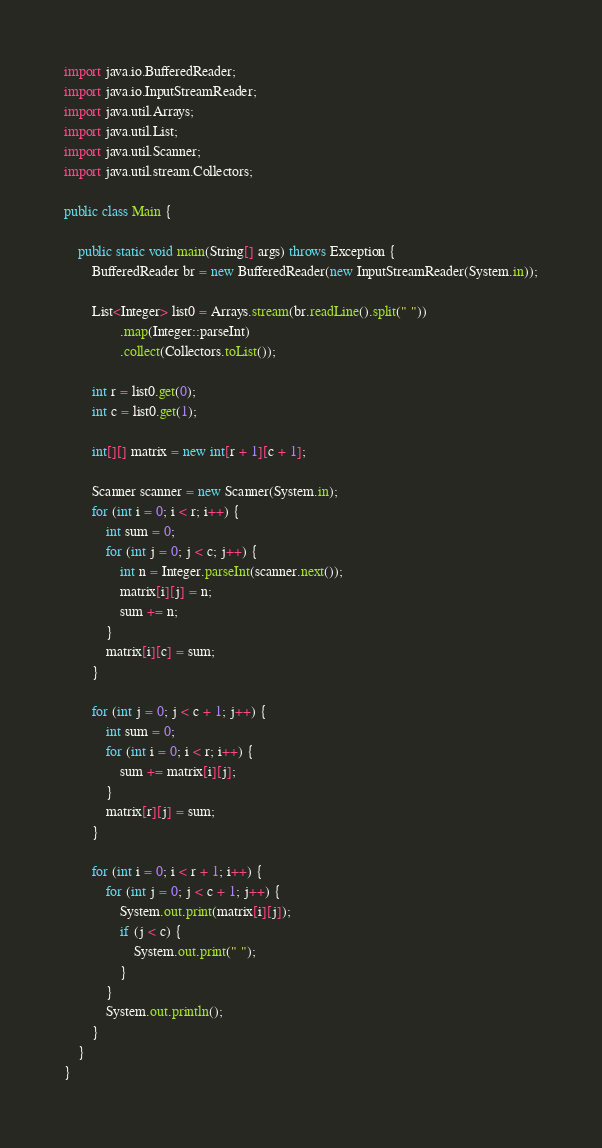Convert code to text. <code><loc_0><loc_0><loc_500><loc_500><_Java_>import java.io.BufferedReader;
import java.io.InputStreamReader;
import java.util.Arrays;
import java.util.List;
import java.util.Scanner;
import java.util.stream.Collectors;

public class Main {

    public static void main(String[] args) throws Exception {
        BufferedReader br = new BufferedReader(new InputStreamReader(System.in));

        List<Integer> list0 = Arrays.stream(br.readLine().split(" "))
                .map(Integer::parseInt)
                .collect(Collectors.toList());

        int r = list0.get(0);
        int c = list0.get(1);

        int[][] matrix = new int[r + 1][c + 1];

        Scanner scanner = new Scanner(System.in);
        for (int i = 0; i < r; i++) {
            int sum = 0;
            for (int j = 0; j < c; j++) {
                int n = Integer.parseInt(scanner.next());
                matrix[i][j] = n;
                sum += n;
            }
            matrix[i][c] = sum;
        }

        for (int j = 0; j < c + 1; j++) {
            int sum = 0;
            for (int i = 0; i < r; i++) {
                sum += matrix[i][j];
            }
            matrix[r][j] = sum;
        }

        for (int i = 0; i < r + 1; i++) {
            for (int j = 0; j < c + 1; j++) {
                System.out.print(matrix[i][j]);
                if (j < c) {
                    System.out.print(" ");
                }
            }
            System.out.println();
        }
    }
}</code> 